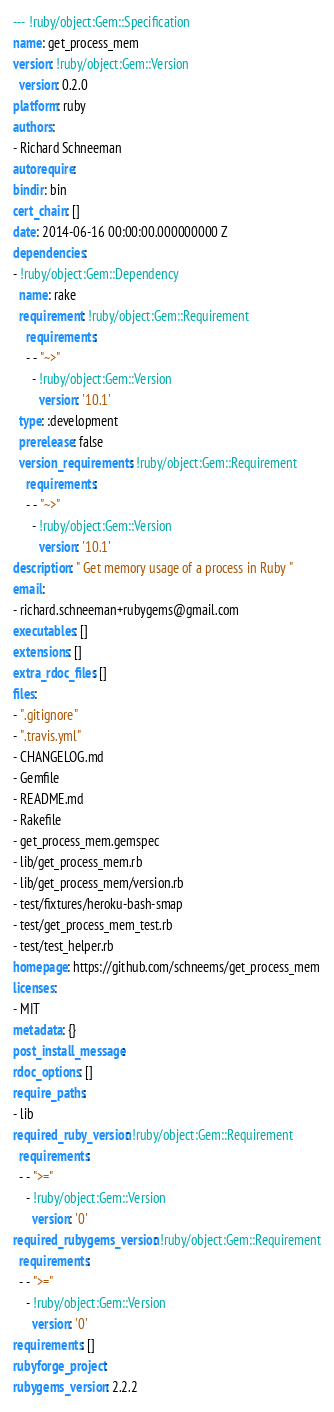<code> <loc_0><loc_0><loc_500><loc_500><_YAML_>--- !ruby/object:Gem::Specification
name: get_process_mem
version: !ruby/object:Gem::Version
  version: 0.2.0
platform: ruby
authors:
- Richard Schneeman
autorequire: 
bindir: bin
cert_chain: []
date: 2014-06-16 00:00:00.000000000 Z
dependencies:
- !ruby/object:Gem::Dependency
  name: rake
  requirement: !ruby/object:Gem::Requirement
    requirements:
    - - "~>"
      - !ruby/object:Gem::Version
        version: '10.1'
  type: :development
  prerelease: false
  version_requirements: !ruby/object:Gem::Requirement
    requirements:
    - - "~>"
      - !ruby/object:Gem::Version
        version: '10.1'
description: " Get memory usage of a process in Ruby "
email:
- richard.schneeman+rubygems@gmail.com
executables: []
extensions: []
extra_rdoc_files: []
files:
- ".gitignore"
- ".travis.yml"
- CHANGELOG.md
- Gemfile
- README.md
- Rakefile
- get_process_mem.gemspec
- lib/get_process_mem.rb
- lib/get_process_mem/version.rb
- test/fixtures/heroku-bash-smap
- test/get_process_mem_test.rb
- test/test_helper.rb
homepage: https://github.com/schneems/get_process_mem
licenses:
- MIT
metadata: {}
post_install_message: 
rdoc_options: []
require_paths:
- lib
required_ruby_version: !ruby/object:Gem::Requirement
  requirements:
  - - ">="
    - !ruby/object:Gem::Version
      version: '0'
required_rubygems_version: !ruby/object:Gem::Requirement
  requirements:
  - - ">="
    - !ruby/object:Gem::Version
      version: '0'
requirements: []
rubyforge_project: 
rubygems_version: 2.2.2</code> 